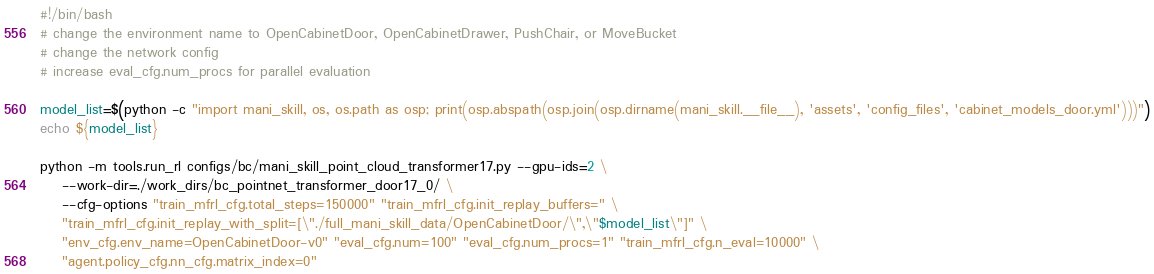Convert code to text. <code><loc_0><loc_0><loc_500><loc_500><_Bash_>#!/bin/bash
# change the environment name to OpenCabinetDoor, OpenCabinetDrawer, PushChair, or MoveBucket
# change the network config
# increase eval_cfg.num_procs for parallel evaluation

model_list=$(python -c "import mani_skill, os, os.path as osp; print(osp.abspath(osp.join(osp.dirname(mani_skill.__file__), 'assets', 'config_files', 'cabinet_models_door.yml')))")
echo ${model_list}

python -m tools.run_rl configs/bc/mani_skill_point_cloud_transformer17.py --gpu-ids=2 \
	--work-dir=./work_dirs/bc_pointnet_transformer_door17_0/ \
	--cfg-options "train_mfrl_cfg.total_steps=150000" "train_mfrl_cfg.init_replay_buffers=" \
	"train_mfrl_cfg.init_replay_with_split=[\"./full_mani_skill_data/OpenCabinetDoor/\",\"$model_list\"]" \
	"env_cfg.env_name=OpenCabinetDoor-v0" "eval_cfg.num=100" "eval_cfg.num_procs=1" "train_mfrl_cfg.n_eval=10000" \
	"agent.policy_cfg.nn_cfg.matrix_index=0"

</code> 